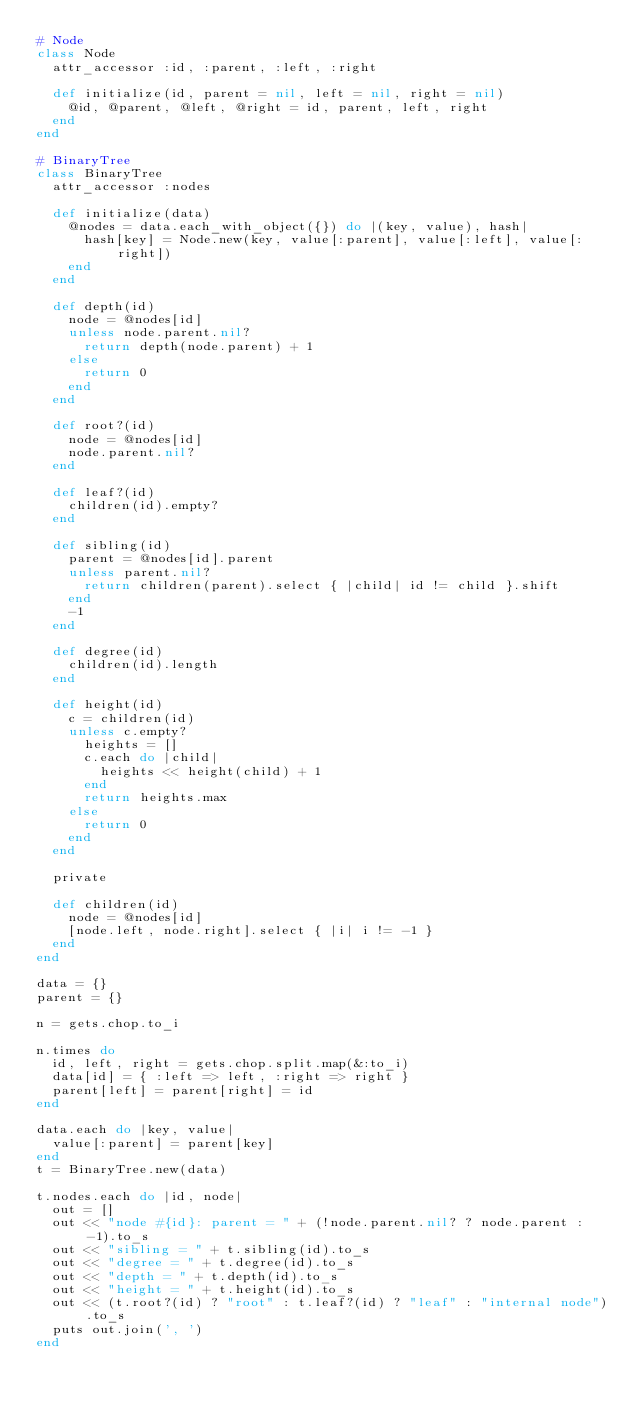<code> <loc_0><loc_0><loc_500><loc_500><_Ruby_># Node
class Node
  attr_accessor :id, :parent, :left, :right

  def initialize(id, parent = nil, left = nil, right = nil)
    @id, @parent, @left, @right = id, parent, left, right
  end
end

# BinaryTree
class BinaryTree
  attr_accessor :nodes

  def initialize(data)
    @nodes = data.each_with_object({}) do |(key, value), hash|
      hash[key] = Node.new(key, value[:parent], value[:left], value[:right])
    end
  end

  def depth(id)
    node = @nodes[id]
    unless node.parent.nil?
      return depth(node.parent) + 1
    else
      return 0
    end
  end

  def root?(id)
    node = @nodes[id]
    node.parent.nil?
  end

  def leaf?(id)
    children(id).empty?
  end

  def sibling(id)
    parent = @nodes[id].parent
    unless parent.nil?
      return children(parent).select { |child| id != child }.shift
    end
    -1
  end

  def degree(id)
    children(id).length
  end

  def height(id)
    c = children(id)
    unless c.empty?
      heights = []
      c.each do |child|
        heights << height(child) + 1
      end
      return heights.max
    else
      return 0
    end
  end

  private

  def children(id)
    node = @nodes[id]
    [node.left, node.right].select { |i| i != -1 }
  end
end

data = {}
parent = {}

n = gets.chop.to_i

n.times do
  id, left, right = gets.chop.split.map(&:to_i)
  data[id] = { :left => left, :right => right }
  parent[left] = parent[right] = id
end

data.each do |key, value|
  value[:parent] = parent[key]
end
t = BinaryTree.new(data)

t.nodes.each do |id, node|
  out = []
  out << "node #{id}: parent = " + (!node.parent.nil? ? node.parent : -1).to_s
  out << "sibling = " + t.sibling(id).to_s
  out << "degree = " + t.degree(id).to_s
  out << "depth = " + t.depth(id).to_s
  out << "height = " + t.height(id).to_s
  out << (t.root?(id) ? "root" : t.leaf?(id) ? "leaf" : "internal node").to_s
  puts out.join(', ')
end</code> 